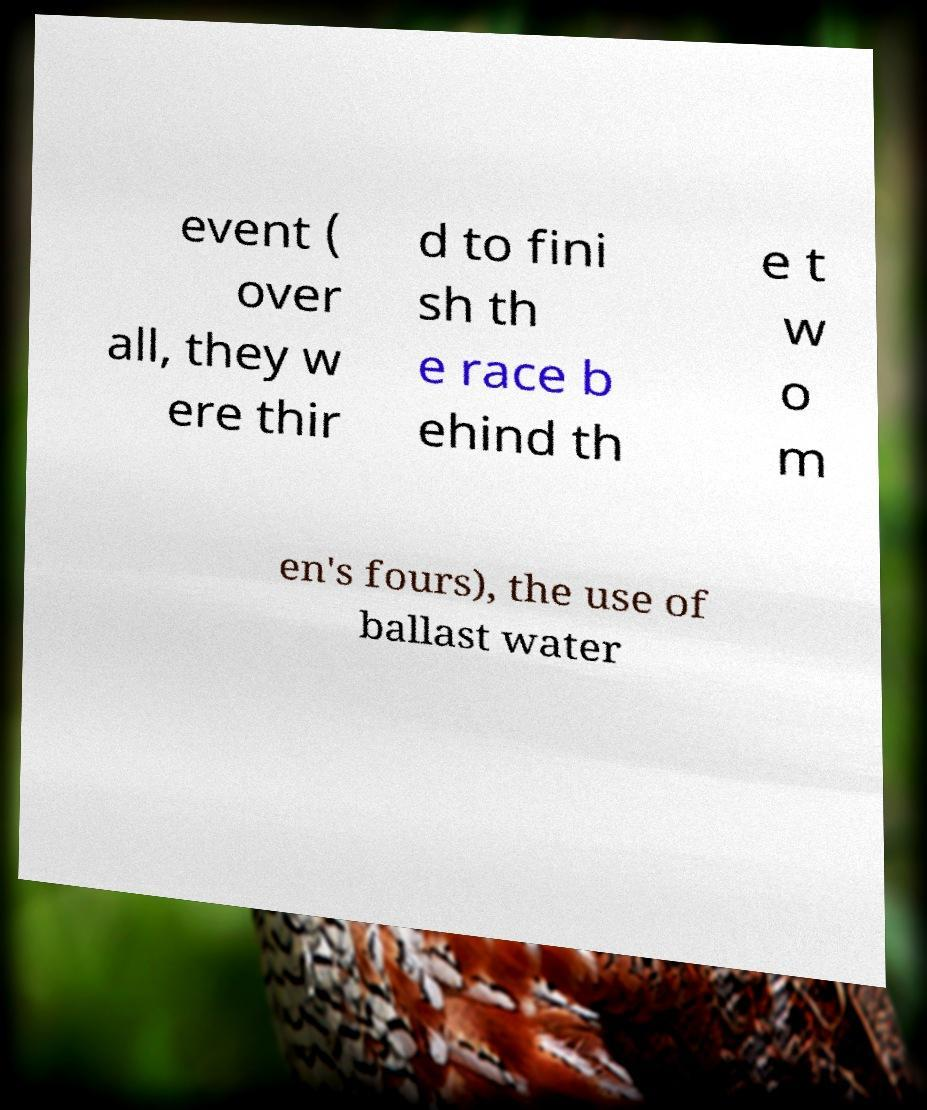Can you accurately transcribe the text from the provided image for me? event ( over all, they w ere thir d to fini sh th e race b ehind th e t w o m en's fours), the use of ballast water 